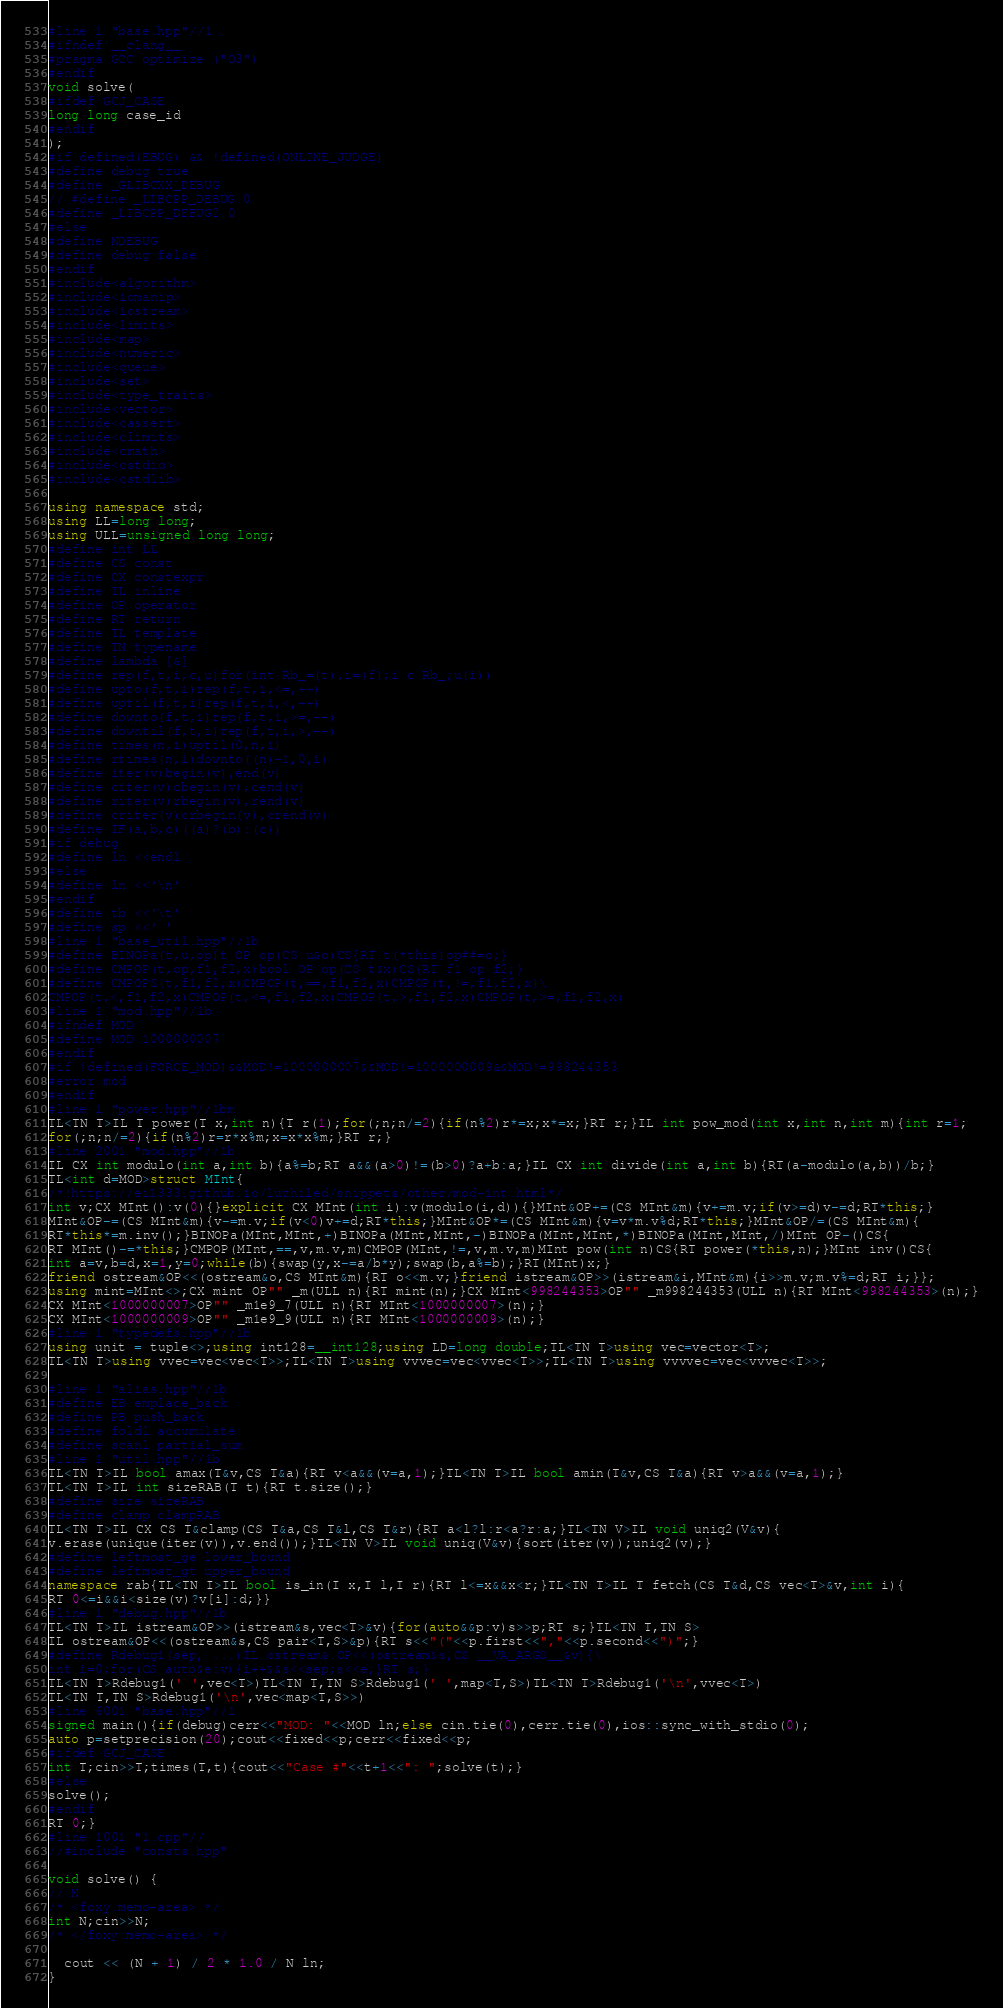<code> <loc_0><loc_0><loc_500><loc_500><_C++_>#line 1 "base.hpp"//1
#ifndef __clang__
#pragma GCC optimize ("O3")
#endif
void solve(
#ifdef GCJ_CASE
long long case_id
#endif
);
#if defined(EBUG) && !defined(ONLINE_JUDGE)
#define debug true
#define _GLIBCXX_DEBUG
// #define _LIBCPP_DEBUG 0
#define _LIBCPP_DEBUG2 0
#else
#define NDEBUG
#define debug false
#endif
#include<algorithm>
#include<iomanip>
#include<iostream>
#include<limits>
#include<map>
#include<numeric>
#include<queue>
#include<set>
#include<type_traits>
#include<vector>
#include<cassert>
#include<climits>
#include<cmath>
#include<cstdio>
#include<cstdlib>

using namespace std;
using LL=long long;
using ULL=unsigned long long;
#define int LL
#define CS const
#define CX constexpr
#define IL inline
#define OP operator
#define RT return
#define TL template
#define TN typename
#define lambda [&]
#define rep(f,t,i,c,u)for(int Rb_=(t),i=(f);i c Rb_;u(i))
#define upto(f,t,i)rep(f,t,i,<=,++)
#define uptil(f,t,i)rep(f,t,i,<,++)
#define downto(f,t,i)rep(f,t,i,>=,--)
#define downtil(f,t,i)rep(f,t,i,>,--)
#define times(n,i)uptil(0,n,i)
#define rtimes(n,i)downto((n)-1,0,i)
#define iter(v)begin(v),end(v)
#define citer(v)cbegin(v),cend(v)
#define riter(v)rbegin(v),rend(v)
#define criter(v)crbegin(v),crend(v)
#define IF(a,b,c)((a)?(b):(c))
#if debug
#define ln <<endl
#else
#define ln <<'\n'
#endif
#define tb <<'\t'
#define sp <<' '
#line 1 "base_util.hpp"//1b
#define BINOPa(t,u,op)t OP op(CS u&o)CS{RT t(*this)op##=o;}
#define CMPOP(t,op,f1,f2,x)bool OP op(CS t&x)CS{RT f1 op f2;}
#define CMPOPS(t,f1,f2,x)CMPOP(t,==,f1,f2,x)CMPOP(t,!=,f1,f2,x)\
CMPOP(t,<,f1,f2,x)CMPOP(t,<=,f1,f2,x)CMPOP(t,>,f1,f2,x)CMPOP(t,>=,f1,f2,x)
#line 1 "mod.hpp"//1b
#ifndef MOD
#define MOD 1000000007
#endif
#if !defined(FORCE_MOD)&&MOD!=1000000007&&MOD!=1000000009&&MOD!=998244353
#error mod
#endif
#line 1 "power.hpp"//1bm
TL<TN T>IL T power(T x,int n){T r(1);for(;n;n/=2){if(n%2)r*=x;x*=x;}RT r;}IL int pow_mod(int x,int n,int m){int r=1;
for(;n;n/=2){if(n%2)r=r*x%m;x=x*x%m;}RT r;}
#line 2001 "mod.hpp"//1b
IL CX int modulo(int a,int b){a%=b;RT a&&(a>0)!=(b>0)?a+b:a;}IL CX int divide(int a,int b){RT(a-modulo(a,b))/b;}
TL<int d=MOD>struct MInt{
/*!https://ei1333.github.io/luzhiled/snippets/other/mod-int.html*/
int v;CX MInt():v(0){}explicit CX MInt(int i):v(modulo(i,d)){}MInt&OP+=(CS MInt&m){v+=m.v;if(v>=d)v-=d;RT*this;}
MInt&OP-=(CS MInt&m){v-=m.v;if(v<0)v+=d;RT*this;}MInt&OP*=(CS MInt&m){v=v*m.v%d;RT*this;}MInt&OP/=(CS MInt&m){
RT*this*=m.inv();}BINOPa(MInt,MInt,+)BINOPa(MInt,MInt,-)BINOPa(MInt,MInt,*)BINOPa(MInt,MInt,/)MInt OP-()CS{
RT MInt()-=*this;}CMPOP(MInt,==,v,m.v,m)CMPOP(MInt,!=,v,m.v,m)MInt pow(int n)CS{RT power(*this,n);}MInt inv()CS{
int a=v,b=d,x=1,y=0;while(b){swap(y,x-=a/b*y);swap(b,a%=b);}RT(MInt)x;}
friend ostream&OP<<(ostream&o,CS MInt&m){RT o<<m.v;}friend istream&OP>>(istream&i,MInt&m){i>>m.v;m.v%=d;RT i;}};
using mint=MInt<>;CX mint OP"" _m(ULL n){RT mint(n);}CX MInt<998244353>OP"" _m998244353(ULL n){RT MInt<998244353>(n);}
CX MInt<1000000007>OP"" _m1e9_7(ULL n){RT MInt<1000000007>(n);}
CX MInt<1000000009>OP"" _m1e9_9(ULL n){RT MInt<1000000009>(n);}
#line 1 "typedefs.hpp"//1b
using unit = tuple<>;using int128=__int128;using LD=long double;TL<TN T>using vec=vector<T>;
TL<TN T>using vvec=vec<vec<T>>;TL<TN T>using vvvec=vec<vvec<T>>;TL<TN T>using vvvvec=vec<vvvec<T>>;

#line 1 "alias.hpp"//1b
#define EB emplace_back
#define PB push_back
#define foldl accumulate
#define scanl partial_sum
#line 1 "util.hpp"//1b
TL<TN T>IL bool amax(T&v,CS T&a){RT v<a&&(v=a,1);}TL<TN T>IL bool amin(T&v,CS T&a){RT v>a&&(v=a,1);}
TL<TN T>IL int sizeRAB(T t){RT t.size();}
#define size sizeRAB
#define clamp clampRAB
TL<TN T>IL CX CS T&clamp(CS T&a,CS T&l,CS T&r){RT a<l?l:r<a?r:a;}TL<TN V>IL void uniq2(V&v){
v.erase(unique(iter(v)),v.end());}TL<TN V>IL void uniq(V&v){sort(iter(v));uniq2(v);}
#define leftmost_ge lower_bound
#define leftmost_gt upper_bound
namespace rab{TL<TN I>IL bool is_in(I x,I l,I r){RT l<=x&&x<r;}TL<TN T>IL T fetch(CS T&d,CS vec<T>&v,int i){
RT 0<=i&&i<size(v)?v[i]:d;}}
#line 1 "debug.hpp"//1b
TL<TN T>IL istream&OP>>(istream&s,vec<T>&v){for(auto&&p:v)s>>p;RT s;}TL<TN T,TN S>
IL ostream&OP<<(ostream&s,CS pair<T,S>&p){RT s<<"("<<p.first<<","<<p.second<<")";}
#define Rdebug1(sep, ...)IL ostream& OP<<(ostream&s,CS __VA_ARGS__&v){\
int i=0;for(CS auto&e:v){i++&&s<<sep;s<<e;}RT s;}
TL<TN T>Rdebug1(' ',vec<T>)TL<TN T,TN S>Rdebug1(' ',map<T,S>)TL<TN T>Rdebug1('\n',vvec<T>)
TL<TN T,TN S>Rdebug1('\n',vec<map<T,S>>)
#line 6001 "base.hpp"//1
signed main(){if(debug)cerr<<"MOD: "<<MOD ln;else cin.tie(0),cerr.tie(0),ios::sync_with_stdio(0);
auto p=setprecision(20);cout<<fixed<<p;cerr<<fixed<<p;
#ifdef GCJ_CASE
int T;cin>>T;times(T,t){cout<<"Case #"<<t+1<<": ";solve(t);}
#else
solve();
#endif
RT 0;}
#line 1001 "1.cpp"//
//#include "consts.hpp"

void solve() {
// N
/* <foxy.memo-area> */
int N;cin>>N;
/* </foxy.memo-area> */

  cout << (N + 1) / 2 * 1.0 / N ln;
}
</code> 